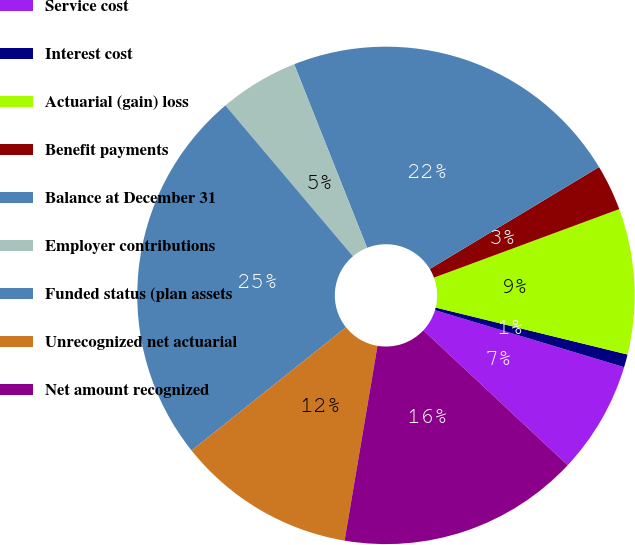Convert chart to OTSL. <chart><loc_0><loc_0><loc_500><loc_500><pie_chart><fcel>Service cost<fcel>Interest cost<fcel>Actuarial (gain) loss<fcel>Benefit payments<fcel>Balance at December 31<fcel>Employer contributions<fcel>Funded status (plan assets<fcel>Unrecognized net actuarial<fcel>Net amount recognized<nl><fcel>7.3%<fcel>0.84%<fcel>9.46%<fcel>2.99%<fcel>22.39%<fcel>5.15%<fcel>24.55%<fcel>11.62%<fcel>15.7%<nl></chart> 